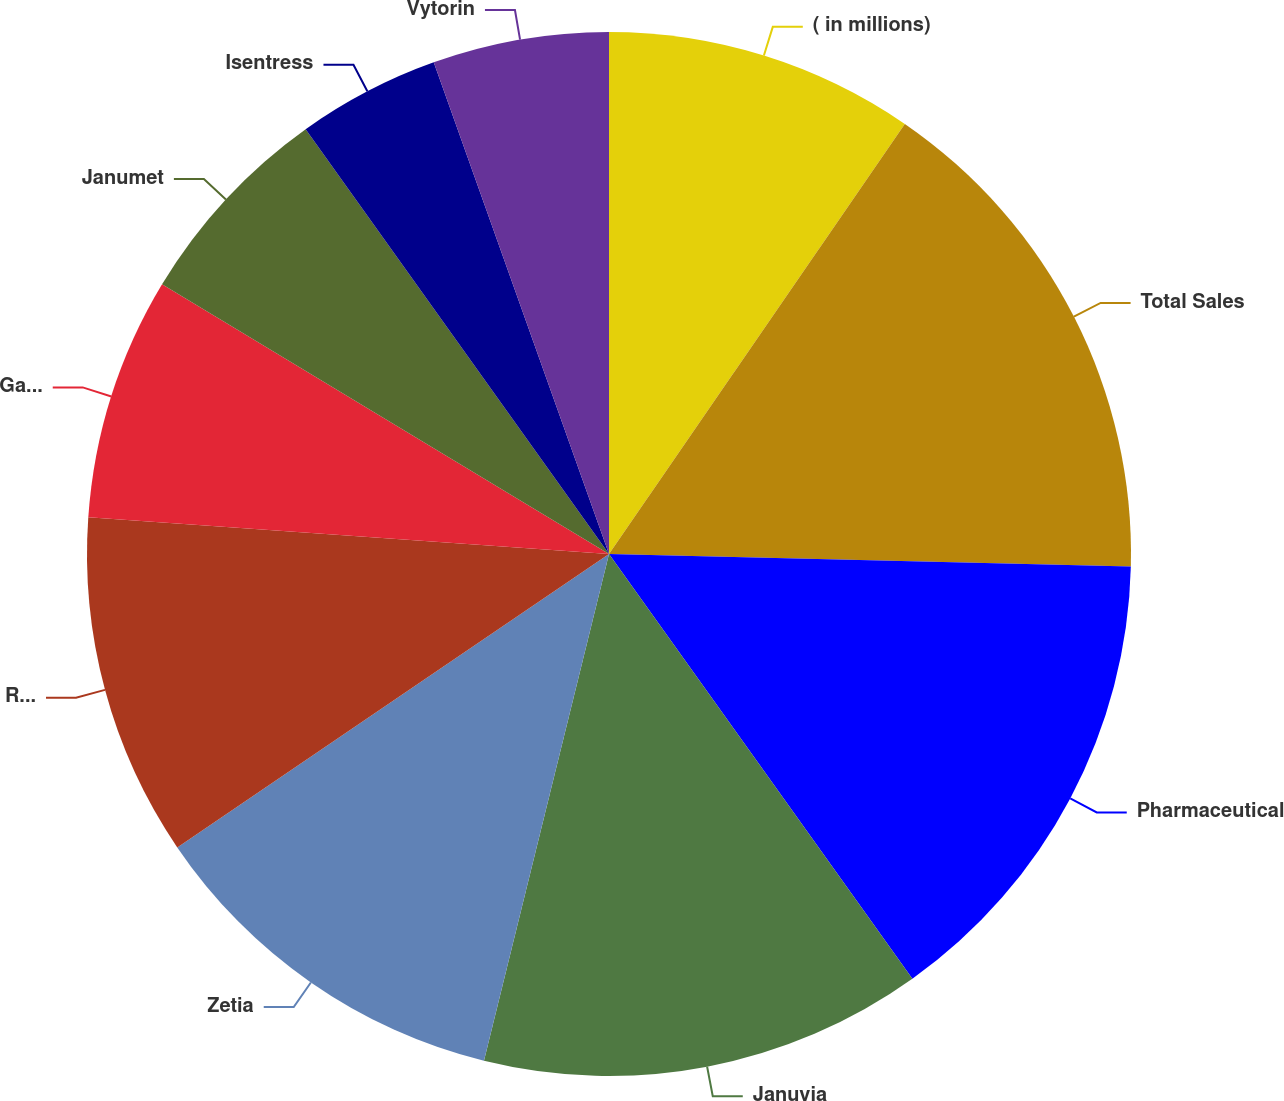Convert chart. <chart><loc_0><loc_0><loc_500><loc_500><pie_chart><fcel>( in millions)<fcel>Total Sales<fcel>Pharmaceutical<fcel>Januvia<fcel>Zetia<fcel>Remicade<fcel>Gardasil<fcel>Janumet<fcel>Isentress<fcel>Vytorin<nl><fcel>9.59%<fcel>15.79%<fcel>14.75%<fcel>13.72%<fcel>11.65%<fcel>10.62%<fcel>7.52%<fcel>6.49%<fcel>4.42%<fcel>5.45%<nl></chart> 